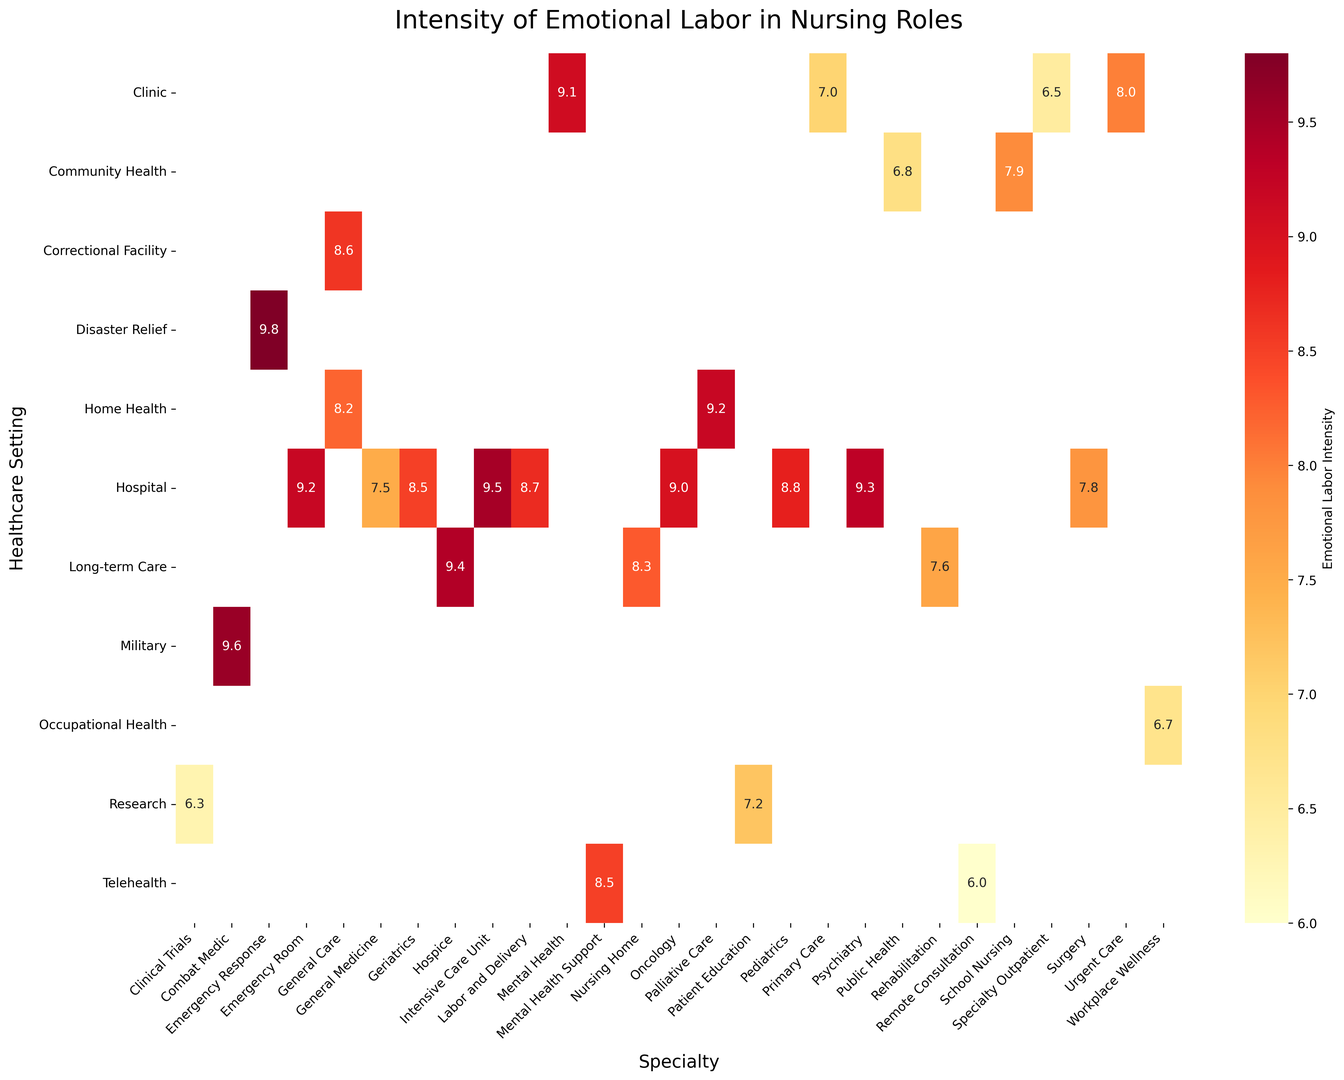Which specialty within the Hospital setting has the highest emotional labor intensity? Look at the 'Hospital' row and identify the cell with the highest number. The highest value in the 'Hospital' row is 9.5, which is in the 'Intensive Care Unit' column.
Answer: Intensive Care Unit What is the difference in emotional labor intensity between the Emergency Room in a Hospital and Remote Consultation in Telehealth? Locate the values for 'Emergency Room' under 'Hospital' (9.2) and 'Remote Consultation' under 'Telehealth' (6.0), then subtract the latter from the former: 9.2 - 6.0.
Answer: 3.2 Which healthcare setting, on average, has the highest emotional labor intensity? Calculate the average emotional labor intensity for each setting. Sum the values for each setting and divide by the number of values. Compare these averages to determine which is highest. Hospital: (9.2+9.5+9.0+8.8+8.5+9.3+8.7+7.8+7.5)/9 = 8.7, Clinic: (7.0+8.0+6.5+9.1)/4 = 7.65, Long-term Care: (8.3+9.4+7.6)/3 = 8.43, Home Health: (8.2+9.2)/2 = 8.7, etc.
Answer: Hospital and Home Health (tie) In the Community Health setting, which specialty has the lowest intensity of emotional labor? Look at the values under the 'Community Health' row and identify the specialty with the lowest number. The lowest value is 6.8, which corresponds to 'Public Health'.
Answer: Public Health Compare the emotional labor intensity in Primary Care (Clinic) and School Nursing (Community Health) and determine which one is higher. Locate the values for 'Primary Care' under 'Clinic' (7.0) and 'School Nursing' under 'Community Health' (7.9). Compare the two values; 7.9 is higher than 7.0.
Answer: School Nursing What is the average emotional labor intensity for specialties in the Telehealth setting? Locate the values for 'Telehealth' and calculate the average. The specialties under 'Telehealth' are 'Remote Consultation' (6.0) and 'Mental Health Support' (8.5). The average is (6.0 + 8.5) / 2.
Answer: 7.25 Which specialty has a higher emotional labor intensity: Mental Health in a Clinic or Psychiatry in a Hospital? Locate the values for 'Mental Health' under 'Clinic' (9.1) and 'Psychiatry' under 'Hospital' (9.3). Compare the two values; 9.3 is greater than 9.1.
Answer: Psychiatry in a Hospital Identify the specialty within the Long-term Care setting with the highest emotional labor intensity. Look at the 'Long-term Care' row and identify the specialty with the highest value. The highest number is 9.4, which corresponds to 'Hospice'.
Answer: Hospice Does Palliative Care in Home Health have a higher emotional labor intensity than Oncology in a Hospital? Locate the values for 'Palliative Care' under 'Home Health' (9.2) and 'Oncology' under 'Hospital' (9.0). Compare the two values; 9.2 is higher than 9.
Answer: Yes Compare the color intensity between the 'Intensive Care Unit' in a Hospital and the 'Rehabilitation' in Long-term Care. Which one appears more intense? The 'Intensive Care Unit' in a Hospital has the value 9.5 and 'Rehabilitation' in Long-term Care has the value 7.6. Higher values correspond to more intense colors (deeper red). Therefore, 'Intensive Care Unit' will appear more intense compared to 'Rehabilitation'.
Answer: Intensive Care Unit 